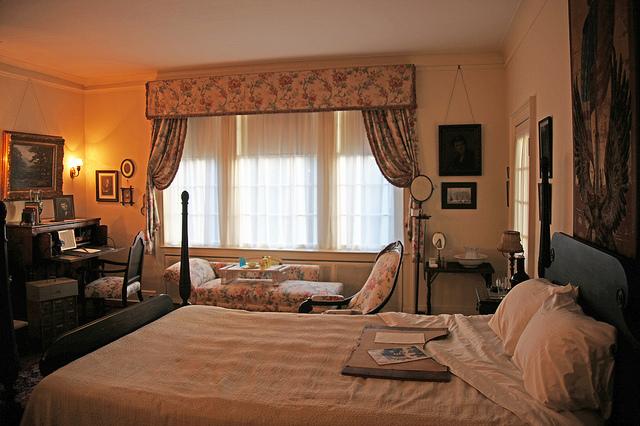Is this bedroom lived in?
Write a very short answer. Yes. Is this room inviting?
Be succinct. Yes. Is the room messy?
Write a very short answer. No. What is the piece of furniture beneath the window called?
Give a very brief answer. Chaise. Is this room comfortably arranged?
Answer briefly. Yes. Where is the phone?
Keep it brief. Table. 